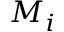<formula> <loc_0><loc_0><loc_500><loc_500>M _ { i }</formula> 